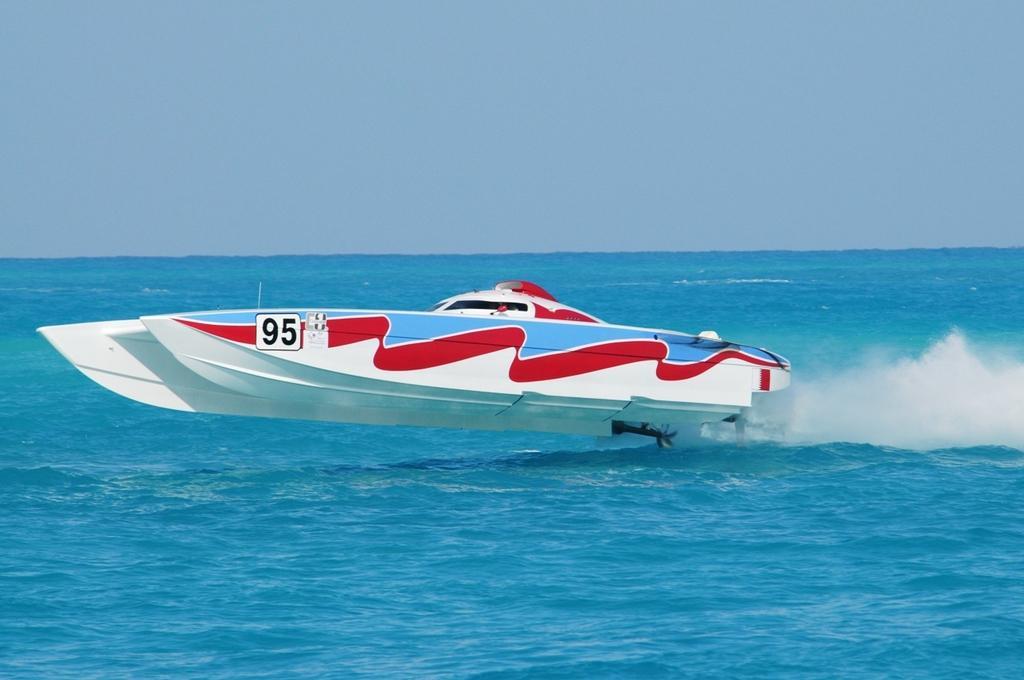Describe this image in one or two sentences. In this image there is a boat sailing on water having few tides. Top of image there is sky. 